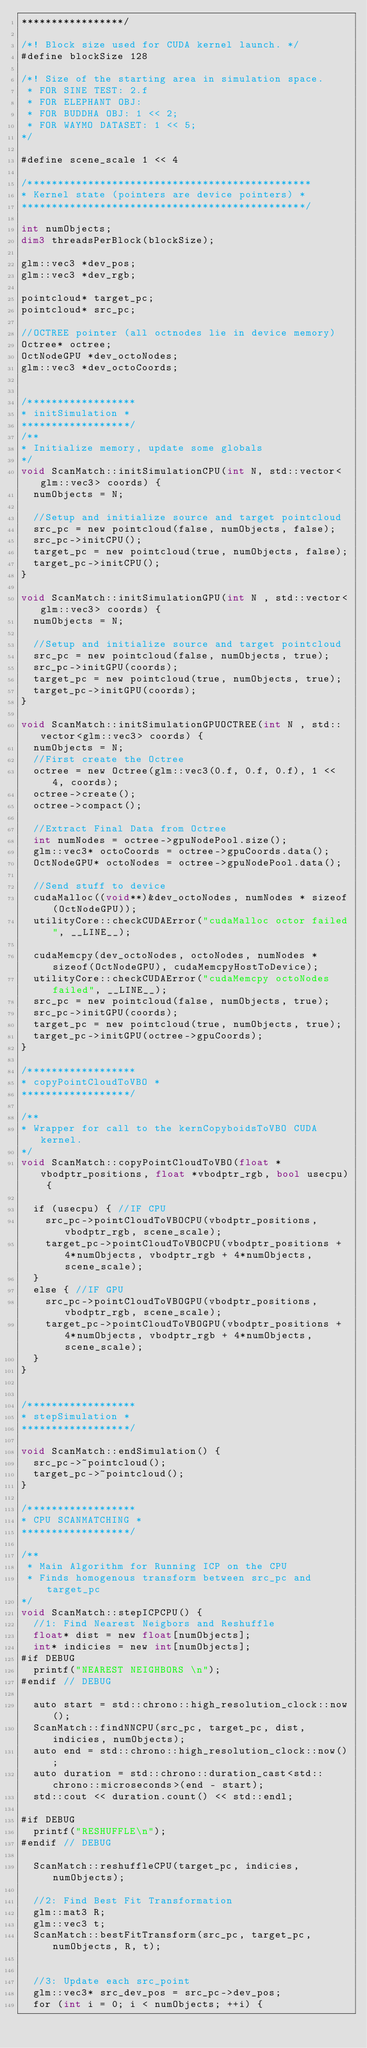Convert code to text. <code><loc_0><loc_0><loc_500><loc_500><_Cuda_>*****************/

/*! Block size used for CUDA kernel launch. */
#define blockSize 128

/*! Size of the starting area in simulation space. 
 * FOR SINE TEST: 2.f
 * FOR ELEPHANT OBJ: 
 * FOR BUDDHA OBJ: 1 << 2;
 * FOR WAYMO DATASET: 1 << 5;
*/

#define scene_scale 1 << 4

/***********************************************
* Kernel state (pointers are device pointers) *
***********************************************/

int numObjects;
dim3 threadsPerBlock(blockSize);

glm::vec3 *dev_pos;
glm::vec3 *dev_rgb;

pointcloud* target_pc;
pointcloud* src_pc;

//OCTREE pointer (all octnodes lie in device memory)
Octree* octree;
OctNodeGPU *dev_octoNodes;
glm::vec3 *dev_octoCoords;


/******************
* initSimulation *
******************/
/**
* Initialize memory, update some globals
*/
void ScanMatch::initSimulationCPU(int N, std::vector<glm::vec3> coords) {
  numObjects = N;

  //Setup and initialize source and target pointcloud
  src_pc = new pointcloud(false, numObjects, false);
  src_pc->initCPU();
  target_pc = new pointcloud(true, numObjects, false);
  target_pc->initCPU();
}

void ScanMatch::initSimulationGPU(int N , std::vector<glm::vec3> coords) {
  numObjects = N;

  //Setup and initialize source and target pointcloud
  src_pc = new pointcloud(false, numObjects, true);
  src_pc->initGPU(coords);
  target_pc = new pointcloud(true, numObjects, true);
  target_pc->initGPU(coords);
}

void ScanMatch::initSimulationGPUOCTREE(int N , std::vector<glm::vec3> coords) {
  numObjects = N;
  //First create the Octree 
  octree = new Octree(glm::vec3(0.f, 0.f, 0.f), 1 << 4, coords);
  octree->create();
  octree->compact();

  //Extract Final Data from Octree
  int numNodes = octree->gpuNodePool.size();
  glm::vec3* octoCoords = octree->gpuCoords.data();
  OctNodeGPU* octoNodes = octree->gpuNodePool.data();

  //Send stuff to device
  cudaMalloc((void**)&dev_octoNodes, numNodes * sizeof(OctNodeGPU));
  utilityCore::checkCUDAError("cudaMalloc octor failed", __LINE__);

  cudaMemcpy(dev_octoNodes, octoNodes, numNodes * sizeof(OctNodeGPU), cudaMemcpyHostToDevice);
  utilityCore::checkCUDAError("cudaMemcpy octoNodes failed", __LINE__);
  src_pc = new pointcloud(false, numObjects, true);
  src_pc->initGPU(coords);
  target_pc = new pointcloud(true, numObjects, true);
  target_pc->initGPU(octree->gpuCoords);
}

/******************
* copyPointCloudToVBO *
******************/

/**
* Wrapper for call to the kernCopyboidsToVBO CUDA kernel.
*/
void ScanMatch::copyPointCloudToVBO(float *vbodptr_positions, float *vbodptr_rgb, bool usecpu) {

	if (usecpu) { //IF CPU
	  src_pc->pointCloudToVBOCPU(vbodptr_positions, vbodptr_rgb, scene_scale);
	  target_pc->pointCloudToVBOCPU(vbodptr_positions + 4*numObjects, vbodptr_rgb + 4*numObjects, scene_scale);
	}
	else { //IF GPU
		src_pc->pointCloudToVBOGPU(vbodptr_positions, vbodptr_rgb, scene_scale);
		target_pc->pointCloudToVBOGPU(vbodptr_positions + 4*numObjects, vbodptr_rgb + 4*numObjects, scene_scale);
	}
}


/******************
* stepSimulation *
******************/

void ScanMatch::endSimulation() {
	src_pc->~pointcloud();
	target_pc->~pointcloud();
}

/******************
* CPU SCANMATCHING *
******************/

/**
 * Main Algorithm for Running ICP on the CPU
 * Finds homogenous transform between src_pc and target_pc 
*/
void ScanMatch::stepICPCPU() {
	//1: Find Nearest Neigbors and Reshuffle
	float* dist = new float[numObjects];
	int* indicies = new int[numObjects];
#if DEBUG
	printf("NEAREST NEIGHBORS \n");
#endif // DEBUG

	auto start = std::chrono::high_resolution_clock::now();
	ScanMatch::findNNCPU(src_pc, target_pc, dist, indicies, numObjects);
	auto end = std::chrono::high_resolution_clock::now();
	auto duration = std::chrono::duration_cast<std::chrono::microseconds>(end - start); 
	std::cout << duration.count() << std::endl;

#if DEBUG
	printf("RESHUFFLE\n");
#endif // DEBUG

	ScanMatch::reshuffleCPU(target_pc, indicies, numObjects);

	//2: Find Best Fit Transformation
	glm::mat3 R;
	glm::vec3 t;
	ScanMatch::bestFitTransform(src_pc, target_pc, numObjects, R, t);


	//3: Update each src_point
	glm::vec3* src_dev_pos = src_pc->dev_pos;
	for (int i = 0; i < numObjects; ++i) {</code> 